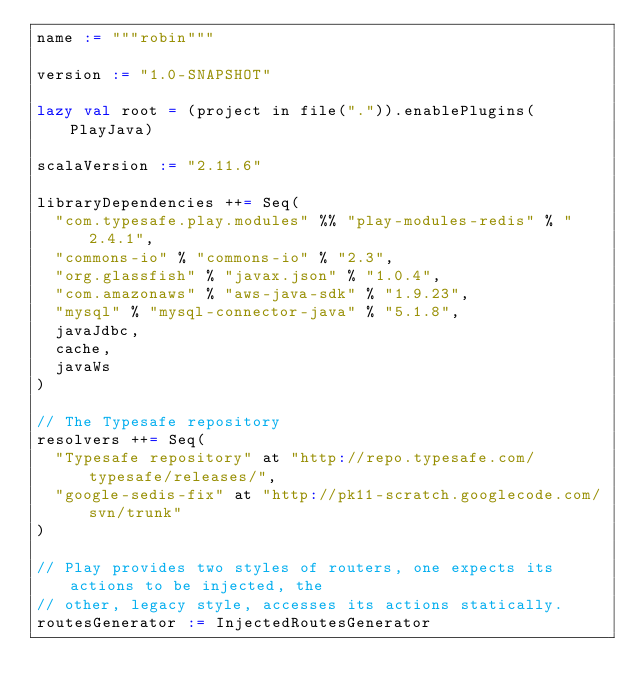<code> <loc_0><loc_0><loc_500><loc_500><_Scala_>name := """robin"""

version := "1.0-SNAPSHOT"

lazy val root = (project in file(".")).enablePlugins(PlayJava)

scalaVersion := "2.11.6"

libraryDependencies ++= Seq(
  "com.typesafe.play.modules" %% "play-modules-redis" % "2.4.1",
  "commons-io" % "commons-io" % "2.3",
  "org.glassfish" % "javax.json" % "1.0.4",
  "com.amazonaws" % "aws-java-sdk" % "1.9.23",
  "mysql" % "mysql-connector-java" % "5.1.8",
  javaJdbc,
  cache,
  javaWs
)

// The Typesafe repository
resolvers ++= Seq(
	"Typesafe repository" at "http://repo.typesafe.com/typesafe/releases/",
	"google-sedis-fix" at "http://pk11-scratch.googlecode.com/svn/trunk"
)

// Play provides two styles of routers, one expects its actions to be injected, the
// other, legacy style, accesses its actions statically.
routesGenerator := InjectedRoutesGenerator
</code> 